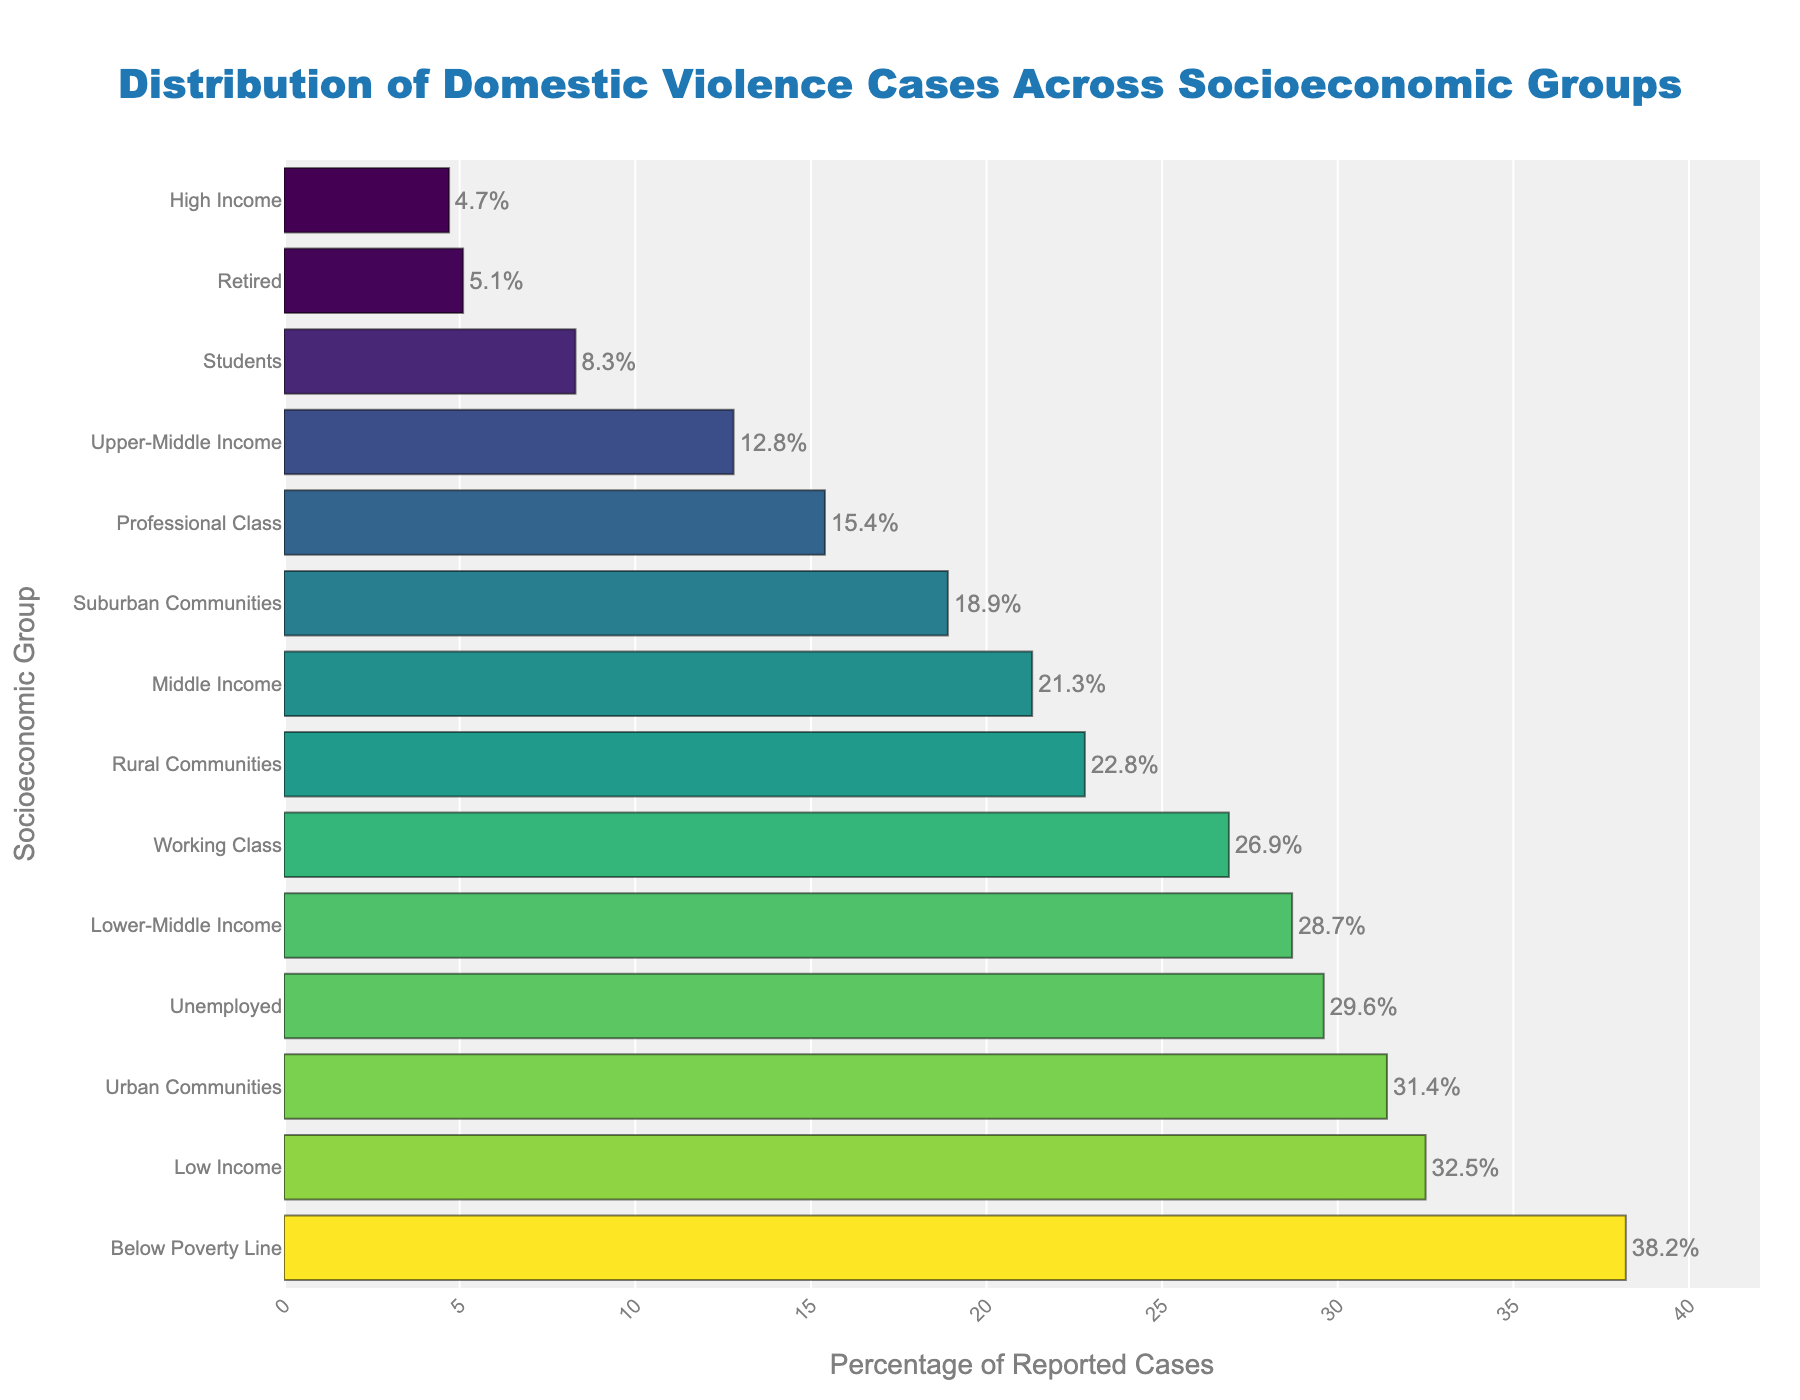which socioeconomic group reports the highest percentage of domestic violence cases? The figure shows the bar chart with different bars representing socioeconomic groups. The tallest bar represents "Below Poverty Line" with a percentage of 38.2.
Answer: Below Poverty Line How much higher is the percentage of cases reported by "Low Income" compared to "High Income"? The percentage of reported cases for "Low Income" is 32.5, and for "High Income" it is 4.7. The difference is 32.5 - 4.7 = 27.8.
Answer: 27.8 What is the combined percentage of reported cases for "Students" and "Retired"? The percentage of reported cases for "Students" is 8.3 and for "Retired" is 5.1. The combined percentage is 8.3 + 5.1 = 13.4.
Answer: 13.4 Which reports more cases, "Urban Communities" or "Rural Communities"? The figure shows that "Urban Communities" have a higher bar compared to "Rural Communities." The reported cases for "Urban Communities" is 31.4, while for "Rural Communities" is 22.8.
Answer: Urban Communities What is the difference between the reported cases of "Unemployed" and "Professional Class"? The percentage of reported cases for "Unemployed" is 29.6 and for "Professional Class" it is 15.4. The difference is 29.6 - 15.4 = 14.2.
Answer: 14.2 What is the median value of reported cases across all groups? To find the median, we need to sort the percentages and find the middle value. Sorted values: 4.7, 5.1, 8.3, 12.8, 15.4, 18.9, 21.3, 22.8, 26.9, 28.7, 29.6, 31.4, 32.5, 38.2. The middle values are 21.3 and 22.8, so the median is (21.3+22.8)/2 = 22.05.
Answer: 22.05 Is the percentage of reported cases for "Middle Income" higher or lower than the average of all groups? First, calculate the average percentage of all groups by summing the percentages and dividing by the number of groups. Sum: 32.5 + 28.7 + 21.3 + 12.8 + 4.7 + 38.2 + 26.9 + 15.4 + 29.6 + 8.3 + 5.1 + 22.8 + 31.4 + 18.9 = 296.6. Average = 296.6 / 14 ≈ 21.2. "Middle Income" is 21.3, which is slightly higher than 21.2.
Answer: Higher Which three groups report the lowest percentage of domestic violence cases? Observing the shorter bars, the three groups with the lowest percentages are "High Income" (4.7), "Retired" (5.1), and "Students" (8.3).
Answer: High Income, Retired, Students 